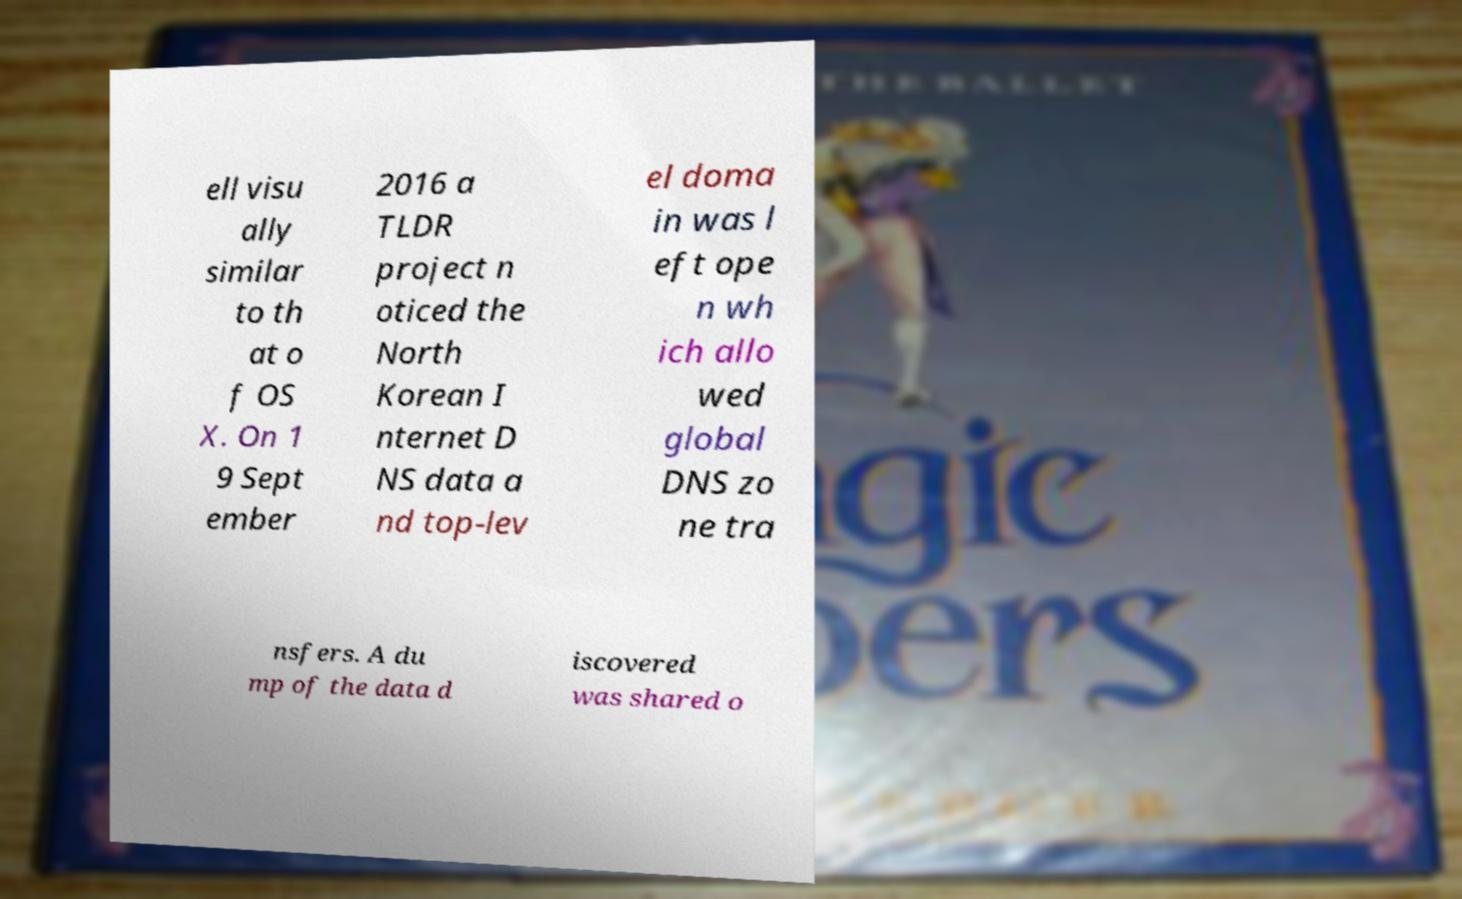Could you assist in decoding the text presented in this image and type it out clearly? ell visu ally similar to th at o f OS X. On 1 9 Sept ember 2016 a TLDR project n oticed the North Korean I nternet D NS data a nd top-lev el doma in was l eft ope n wh ich allo wed global DNS zo ne tra nsfers. A du mp of the data d iscovered was shared o 